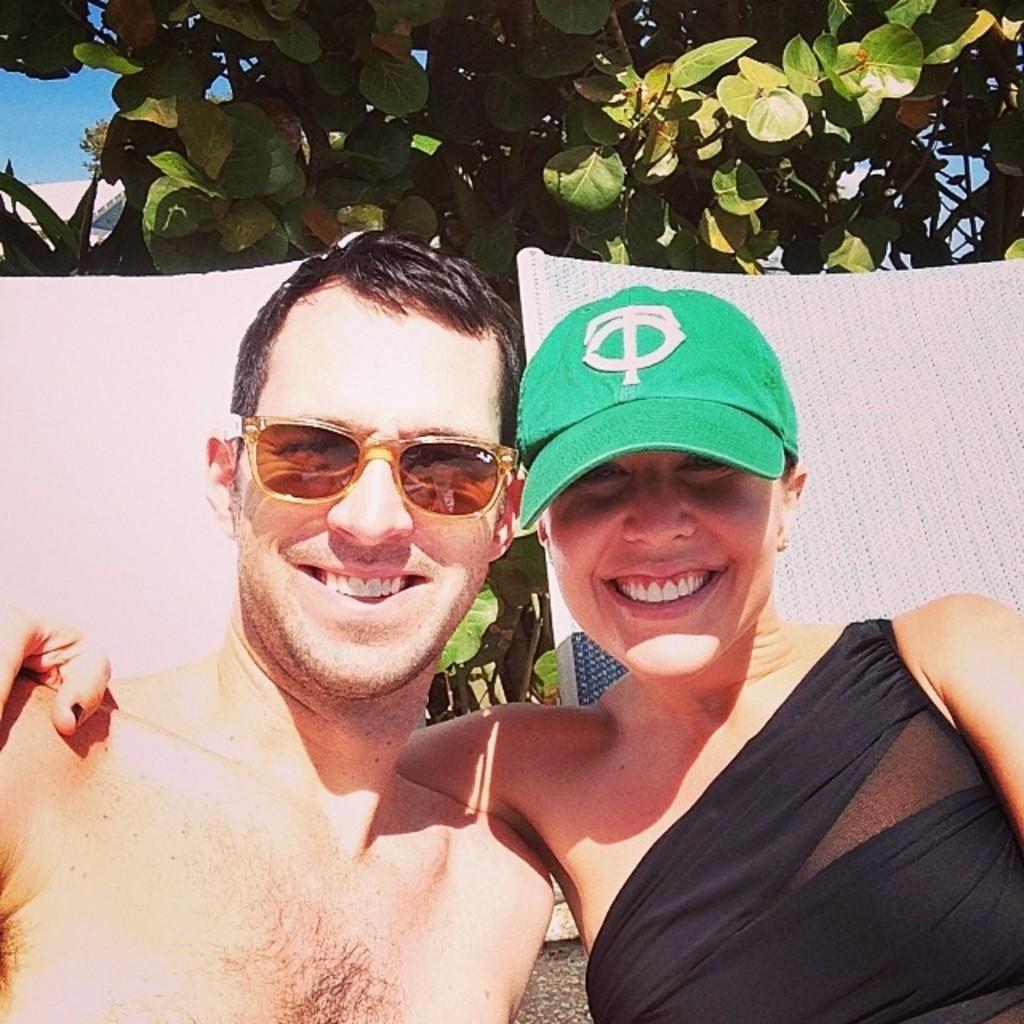Can you describe this image briefly? On the right side, there is a woman in a black color dress, wearing a green color cap, smiling and keeping a hand on the shoulder of a man who is wearing a sunglasses and is smiling. In the background, there are trees and there is blue sky. 